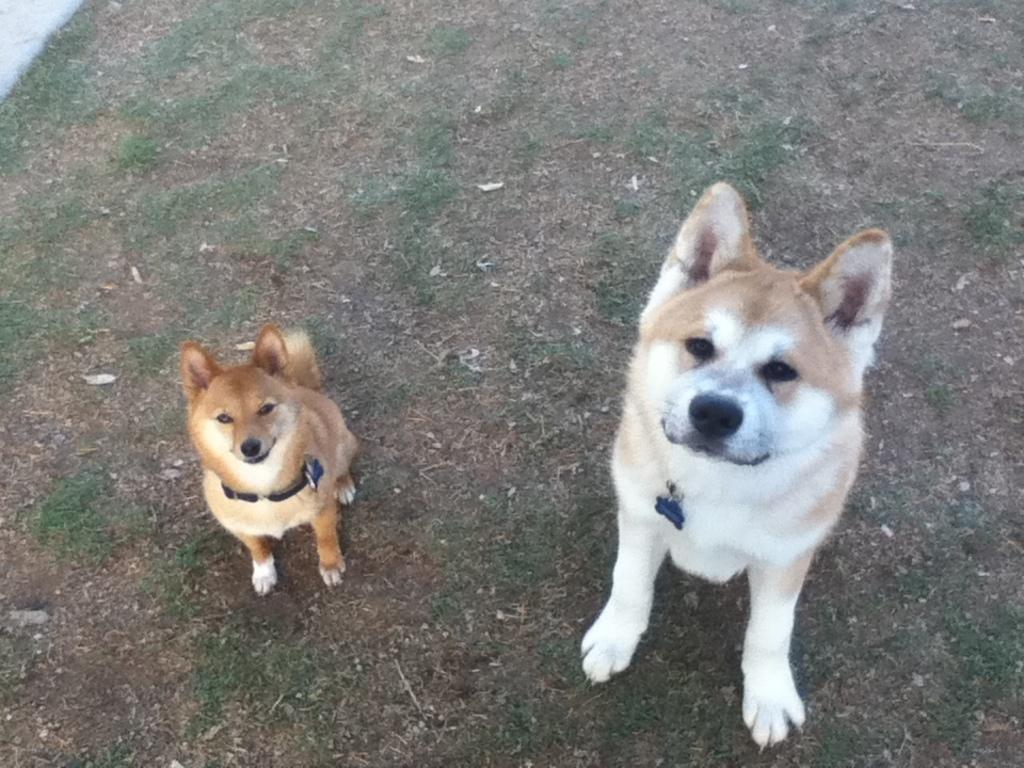How many dogs are in the image? There are two dogs in the image. What colors are the dogs? The dogs are in brown and white color. What type of environment can be seen in the background of the image? There is grass visible in the background of the image. What type of art is displayed on the wall behind the dogs in the image? There is no wall or art visible in the image; it only features the two dogs and grass in the background. 